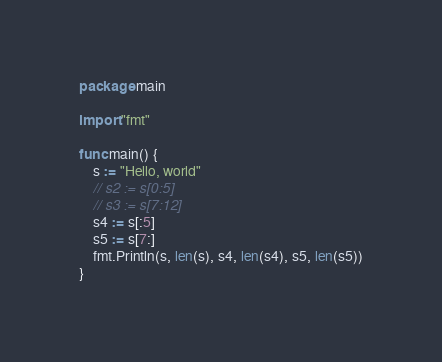<code> <loc_0><loc_0><loc_500><loc_500><_Go_>package main

import "fmt"

func main() {
	s := "Hello, world"
	// s2 := s[0:5]
	// s3 := s[7:12]
	s4 := s[:5]
	s5 := s[7:]
	fmt.Println(s, len(s), s4, len(s4), s5, len(s5))
}
</code> 